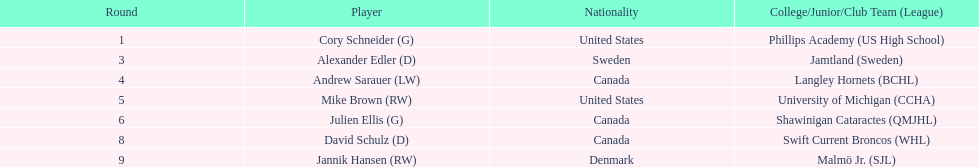Itemize only the american competitors. Cory Schneider (G), Mike Brown (RW). 